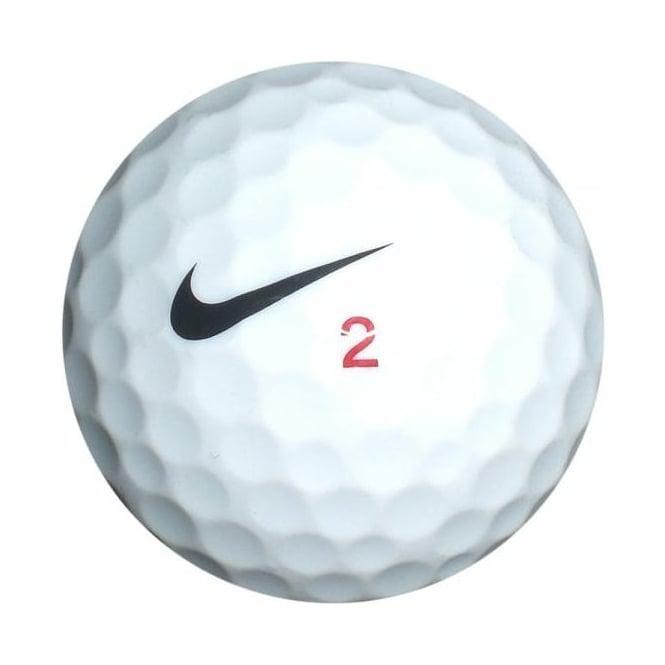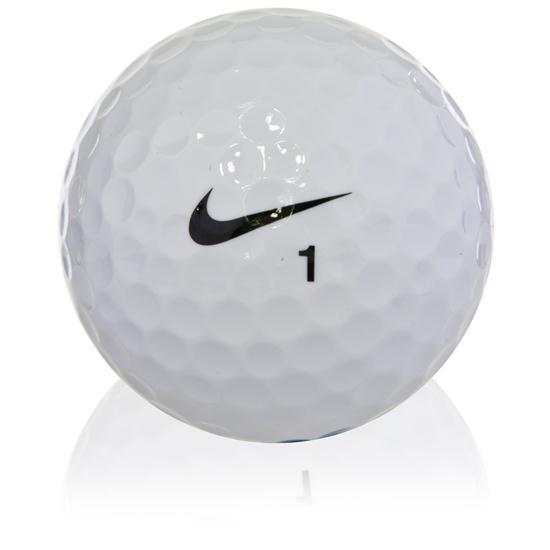The first image is the image on the left, the second image is the image on the right. Evaluate the accuracy of this statement regarding the images: "The number 1 is on exactly one of the balls.". Is it true? Answer yes or no. Yes. 